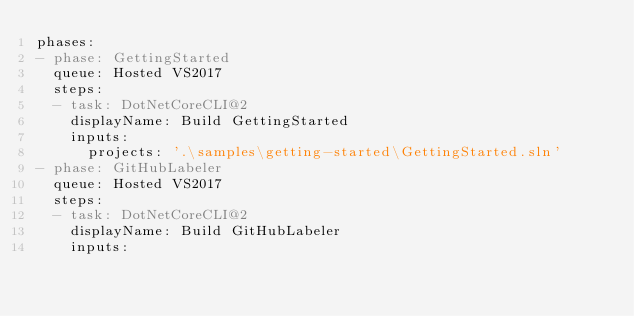<code> <loc_0><loc_0><loc_500><loc_500><_YAML_>phases:
- phase: GettingStarted
  queue: Hosted VS2017
  steps:
  - task: DotNetCoreCLI@2
    displayName: Build GettingStarted
    inputs:
      projects: '.\samples\getting-started\GettingStarted.sln'
- phase: GitHubLabeler
  queue: Hosted VS2017
  steps:
  - task: DotNetCoreCLI@2
    displayName: Build GitHubLabeler
    inputs:</code> 